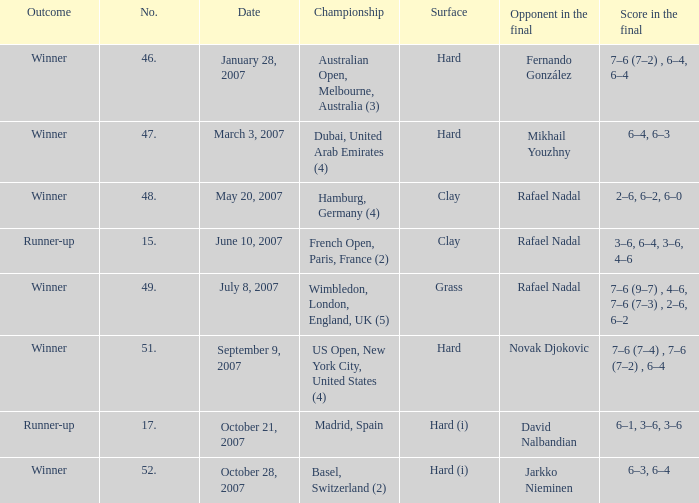Where is the championship where 6–1, 3–6, 3–6 is the score in the final? Madrid, Spain. 